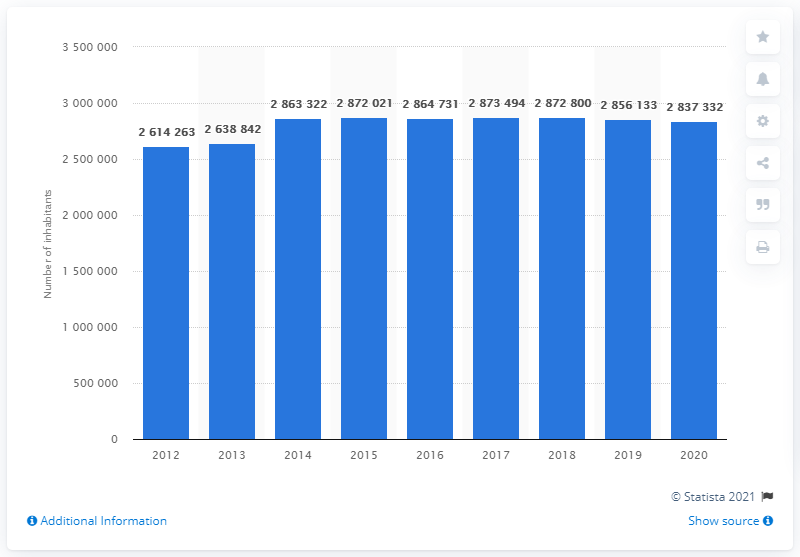List a handful of essential elements in this visual. In the year 2012, the population of Rome was approximately 2,614,263 people. 